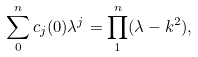<formula> <loc_0><loc_0><loc_500><loc_500>\sum _ { 0 } ^ { n } c _ { j } ( 0 ) \lambda ^ { j } = \prod _ { 1 } ^ { n } ( \lambda - k ^ { 2 } ) ,</formula> 